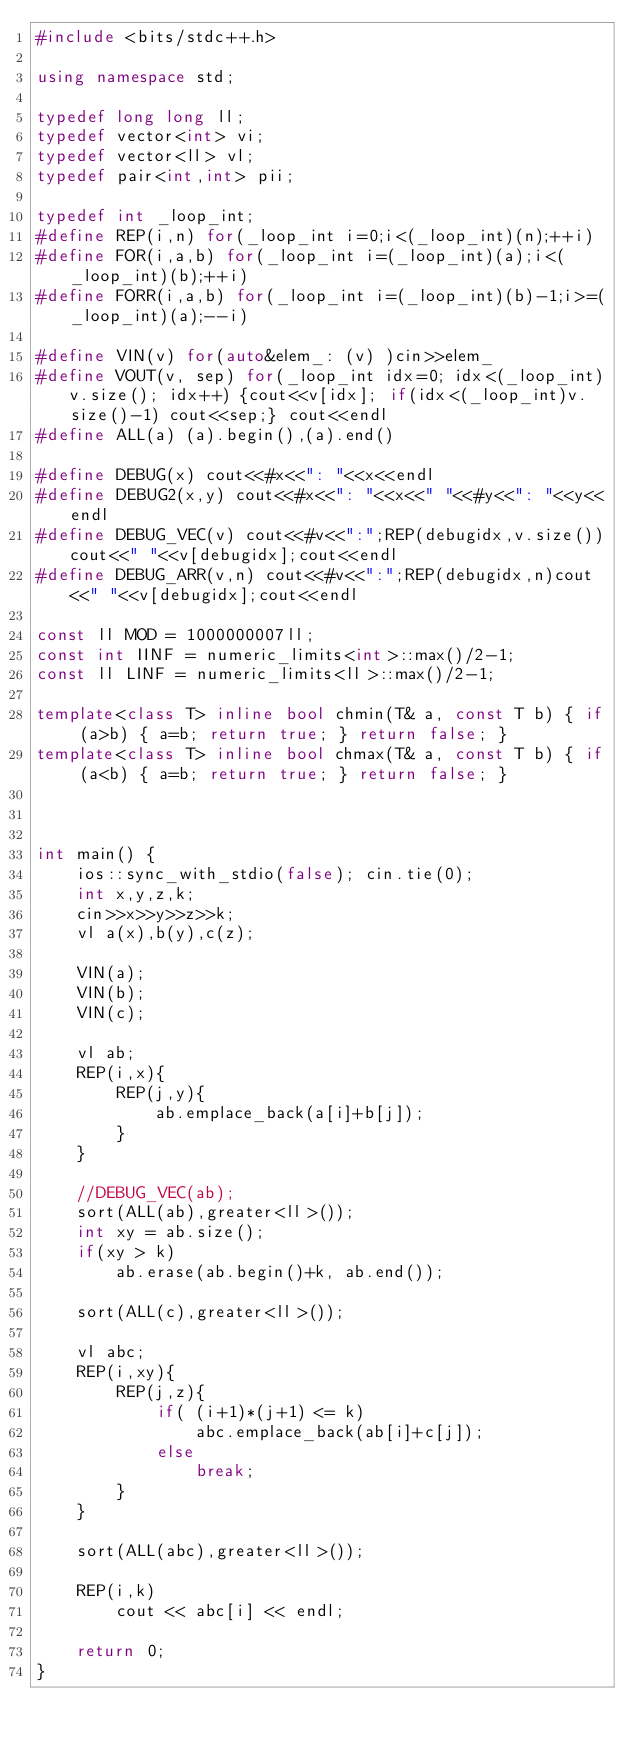<code> <loc_0><loc_0><loc_500><loc_500><_C++_>#include <bits/stdc++.h>

using namespace std;

typedef long long ll;
typedef vector<int> vi;
typedef vector<ll> vl;
typedef pair<int,int> pii;

typedef int _loop_int;
#define REP(i,n) for(_loop_int i=0;i<(_loop_int)(n);++i)
#define FOR(i,a,b) for(_loop_int i=(_loop_int)(a);i<(_loop_int)(b);++i)
#define FORR(i,a,b) for(_loop_int i=(_loop_int)(b)-1;i>=(_loop_int)(a);--i)

#define VIN(v) for(auto&elem_: (v) )cin>>elem_
#define VOUT(v, sep) for(_loop_int idx=0; idx<(_loop_int)v.size(); idx++) {cout<<v[idx]; if(idx<(_loop_int)v.size()-1) cout<<sep;} cout<<endl
#define ALL(a) (a).begin(),(a).end()

#define DEBUG(x) cout<<#x<<": "<<x<<endl
#define DEBUG2(x,y) cout<<#x<<": "<<x<<" "<<#y<<": "<<y<<endl
#define DEBUG_VEC(v) cout<<#v<<":";REP(debugidx,v.size())cout<<" "<<v[debugidx];cout<<endl
#define DEBUG_ARR(v,n) cout<<#v<<":";REP(debugidx,n)cout<<" "<<v[debugidx];cout<<endl

const ll MOD = 1000000007ll;
const int IINF = numeric_limits<int>::max()/2-1;
const ll LINF = numeric_limits<ll>::max()/2-1;

template<class T> inline bool chmin(T& a, const T b) { if (a>b) { a=b; return true; } return false; }
template<class T> inline bool chmax(T& a, const T b) { if (a<b) { a=b; return true; } return false; }



int main() {
    ios::sync_with_stdio(false); cin.tie(0);
    int x,y,z,k;
    cin>>x>>y>>z>>k;
    vl a(x),b(y),c(z);

    VIN(a);
    VIN(b);
    VIN(c);
    
    vl ab;
    REP(i,x){
        REP(j,y){
            ab.emplace_back(a[i]+b[j]);
        }
    }

    //DEBUG_VEC(ab);
    sort(ALL(ab),greater<ll>());
    int xy = ab.size();
    if(xy > k)
        ab.erase(ab.begin()+k, ab.end());
    
    sort(ALL(c),greater<ll>());

    vl abc;
    REP(i,xy){
        REP(j,z){
            if( (i+1)*(j+1) <= k)
                abc.emplace_back(ab[i]+c[j]);
            else
                break;
        }
    }

    sort(ALL(abc),greater<ll>());

    REP(i,k)
        cout << abc[i] << endl;

    return 0;
}</code> 